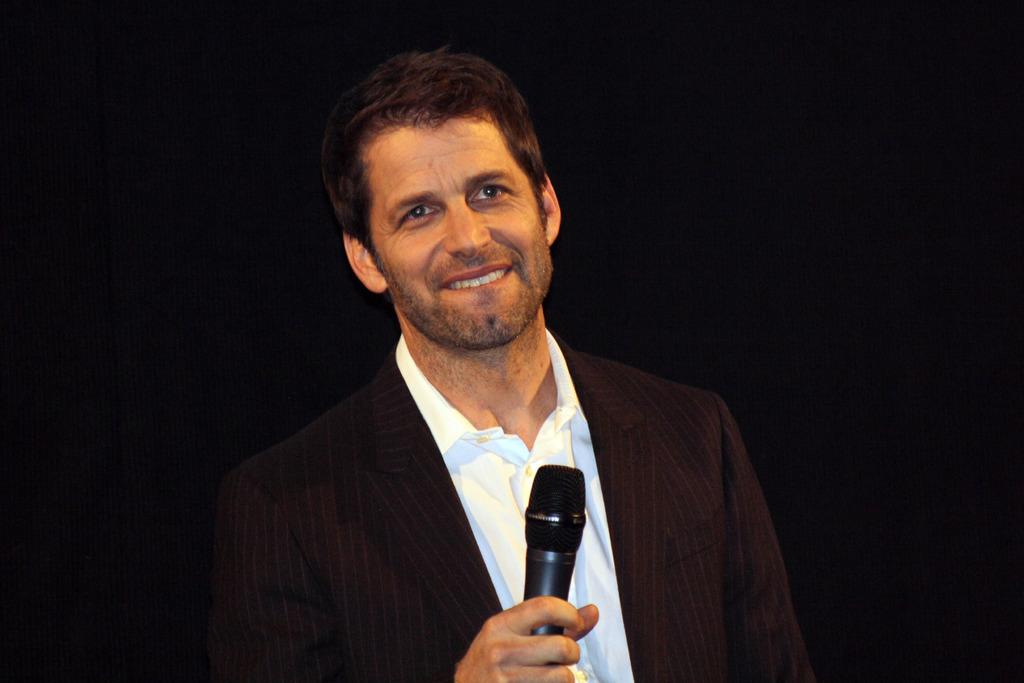What is the main subject of the image? The main subject of the image is a man. What is the man holding in the image? The man is holding a microphone. Can you see a band playing on the edge of the clover in the image? There is no band or clover present in the image; it only features a man holding a microphone. 